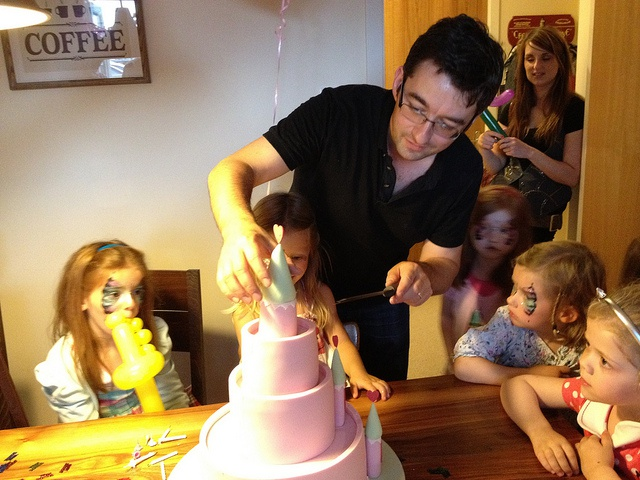Describe the objects in this image and their specific colors. I can see people in gray, black, brown, maroon, and khaki tones, dining table in gray, maroon, gold, and yellow tones, cake in gray, ivory, lightpink, brown, and tan tones, people in gray, olive, ivory, khaki, and orange tones, and people in gray, orange, brown, khaki, and salmon tones in this image. 